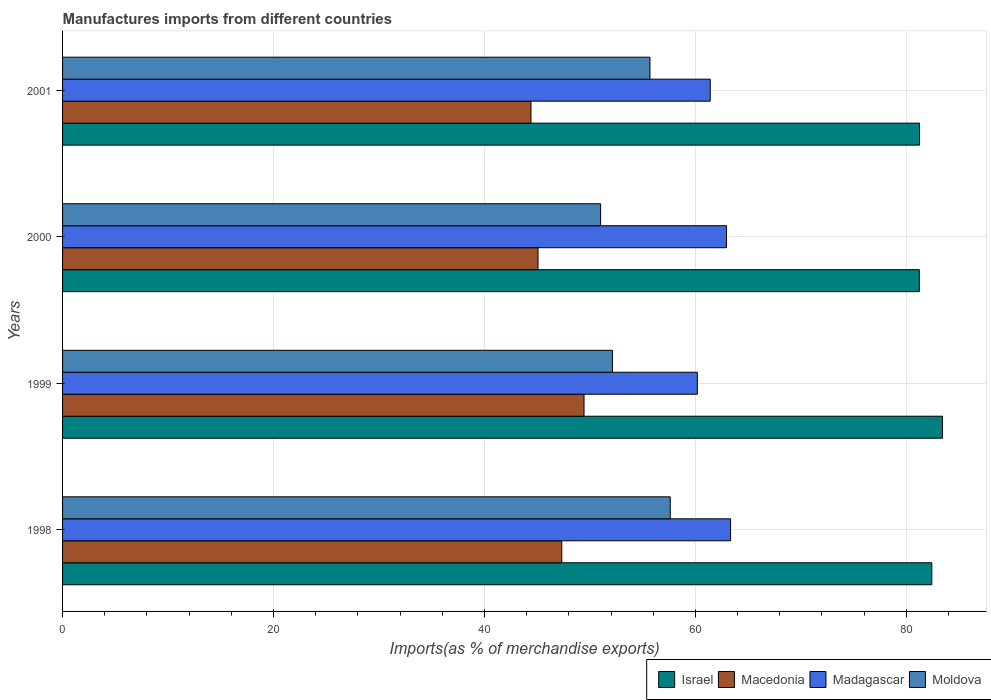How many groups of bars are there?
Provide a succinct answer. 4. Are the number of bars on each tick of the Y-axis equal?
Offer a very short reply. Yes. How many bars are there on the 1st tick from the top?
Ensure brevity in your answer.  4. In how many cases, is the number of bars for a given year not equal to the number of legend labels?
Your answer should be compact. 0. What is the percentage of imports to different countries in Madagascar in 2000?
Make the answer very short. 62.95. Across all years, what is the maximum percentage of imports to different countries in Moldova?
Provide a short and direct response. 57.62. Across all years, what is the minimum percentage of imports to different countries in Israel?
Your answer should be very brief. 81.23. In which year was the percentage of imports to different countries in Israel maximum?
Ensure brevity in your answer.  1999. What is the total percentage of imports to different countries in Madagascar in the graph?
Your answer should be very brief. 247.88. What is the difference between the percentage of imports to different countries in Macedonia in 2000 and that in 2001?
Your answer should be compact. 0.66. What is the difference between the percentage of imports to different countries in Madagascar in 2000 and the percentage of imports to different countries in Macedonia in 1998?
Provide a succinct answer. 15.62. What is the average percentage of imports to different countries in Israel per year?
Offer a terse response. 82.08. In the year 1999, what is the difference between the percentage of imports to different countries in Madagascar and percentage of imports to different countries in Israel?
Give a very brief answer. -23.25. What is the ratio of the percentage of imports to different countries in Israel in 1999 to that in 2000?
Your response must be concise. 1.03. Is the percentage of imports to different countries in Israel in 1998 less than that in 2000?
Make the answer very short. No. Is the difference between the percentage of imports to different countries in Madagascar in 1999 and 2000 greater than the difference between the percentage of imports to different countries in Israel in 1999 and 2000?
Ensure brevity in your answer.  No. What is the difference between the highest and the second highest percentage of imports to different countries in Israel?
Give a very brief answer. 1.01. What is the difference between the highest and the lowest percentage of imports to different countries in Israel?
Ensure brevity in your answer.  2.2. Is the sum of the percentage of imports to different countries in Moldova in 1998 and 2001 greater than the maximum percentage of imports to different countries in Macedonia across all years?
Your answer should be compact. Yes. What does the 3rd bar from the top in 2000 represents?
Keep it short and to the point. Macedonia. What does the 4th bar from the bottom in 2001 represents?
Keep it short and to the point. Moldova. How many bars are there?
Offer a terse response. 16. Are all the bars in the graph horizontal?
Your answer should be compact. Yes. How many years are there in the graph?
Your answer should be very brief. 4. What is the difference between two consecutive major ticks on the X-axis?
Offer a very short reply. 20. Are the values on the major ticks of X-axis written in scientific E-notation?
Keep it short and to the point. No. Does the graph contain any zero values?
Your answer should be compact. No. Does the graph contain grids?
Provide a short and direct response. Yes. Where does the legend appear in the graph?
Provide a short and direct response. Bottom right. What is the title of the graph?
Provide a succinct answer. Manufactures imports from different countries. Does "Belgium" appear as one of the legend labels in the graph?
Give a very brief answer. No. What is the label or title of the X-axis?
Your answer should be compact. Imports(as % of merchandise exports). What is the Imports(as % of merchandise exports) in Israel in 1998?
Your answer should be very brief. 82.42. What is the Imports(as % of merchandise exports) of Macedonia in 1998?
Give a very brief answer. 47.33. What is the Imports(as % of merchandise exports) of Madagascar in 1998?
Ensure brevity in your answer.  63.33. What is the Imports(as % of merchandise exports) in Moldova in 1998?
Make the answer very short. 57.62. What is the Imports(as % of merchandise exports) of Israel in 1999?
Your answer should be very brief. 83.43. What is the Imports(as % of merchandise exports) in Macedonia in 1999?
Your answer should be very brief. 49.44. What is the Imports(as % of merchandise exports) of Madagascar in 1999?
Offer a terse response. 60.18. What is the Imports(as % of merchandise exports) of Moldova in 1999?
Provide a short and direct response. 52.14. What is the Imports(as % of merchandise exports) in Israel in 2000?
Make the answer very short. 81.23. What is the Imports(as % of merchandise exports) of Macedonia in 2000?
Give a very brief answer. 45.08. What is the Imports(as % of merchandise exports) in Madagascar in 2000?
Offer a terse response. 62.95. What is the Imports(as % of merchandise exports) of Moldova in 2000?
Your answer should be very brief. 51.02. What is the Imports(as % of merchandise exports) of Israel in 2001?
Your answer should be compact. 81.25. What is the Imports(as % of merchandise exports) in Macedonia in 2001?
Ensure brevity in your answer.  44.41. What is the Imports(as % of merchandise exports) in Madagascar in 2001?
Give a very brief answer. 61.41. What is the Imports(as % of merchandise exports) of Moldova in 2001?
Provide a succinct answer. 55.69. Across all years, what is the maximum Imports(as % of merchandise exports) in Israel?
Your answer should be very brief. 83.43. Across all years, what is the maximum Imports(as % of merchandise exports) of Macedonia?
Your answer should be very brief. 49.44. Across all years, what is the maximum Imports(as % of merchandise exports) of Madagascar?
Your response must be concise. 63.33. Across all years, what is the maximum Imports(as % of merchandise exports) in Moldova?
Provide a short and direct response. 57.62. Across all years, what is the minimum Imports(as % of merchandise exports) in Israel?
Your answer should be very brief. 81.23. Across all years, what is the minimum Imports(as % of merchandise exports) of Macedonia?
Your response must be concise. 44.41. Across all years, what is the minimum Imports(as % of merchandise exports) of Madagascar?
Make the answer very short. 60.18. Across all years, what is the minimum Imports(as % of merchandise exports) of Moldova?
Offer a very short reply. 51.02. What is the total Imports(as % of merchandise exports) of Israel in the graph?
Offer a terse response. 328.33. What is the total Imports(as % of merchandise exports) in Macedonia in the graph?
Provide a short and direct response. 186.27. What is the total Imports(as % of merchandise exports) in Madagascar in the graph?
Ensure brevity in your answer.  247.88. What is the total Imports(as % of merchandise exports) in Moldova in the graph?
Your answer should be very brief. 216.46. What is the difference between the Imports(as % of merchandise exports) of Israel in 1998 and that in 1999?
Offer a terse response. -1.01. What is the difference between the Imports(as % of merchandise exports) of Macedonia in 1998 and that in 1999?
Your answer should be compact. -2.11. What is the difference between the Imports(as % of merchandise exports) of Madagascar in 1998 and that in 1999?
Make the answer very short. 3.15. What is the difference between the Imports(as % of merchandise exports) of Moldova in 1998 and that in 1999?
Give a very brief answer. 5.48. What is the difference between the Imports(as % of merchandise exports) in Israel in 1998 and that in 2000?
Give a very brief answer. 1.18. What is the difference between the Imports(as % of merchandise exports) of Macedonia in 1998 and that in 2000?
Provide a short and direct response. 2.26. What is the difference between the Imports(as % of merchandise exports) of Madagascar in 1998 and that in 2000?
Offer a terse response. 0.39. What is the difference between the Imports(as % of merchandise exports) of Moldova in 1998 and that in 2000?
Your answer should be compact. 6.6. What is the difference between the Imports(as % of merchandise exports) in Israel in 1998 and that in 2001?
Offer a terse response. 1.16. What is the difference between the Imports(as % of merchandise exports) of Macedonia in 1998 and that in 2001?
Ensure brevity in your answer.  2.92. What is the difference between the Imports(as % of merchandise exports) of Madagascar in 1998 and that in 2001?
Your response must be concise. 1.93. What is the difference between the Imports(as % of merchandise exports) of Moldova in 1998 and that in 2001?
Ensure brevity in your answer.  1.92. What is the difference between the Imports(as % of merchandise exports) of Israel in 1999 and that in 2000?
Give a very brief answer. 2.2. What is the difference between the Imports(as % of merchandise exports) in Macedonia in 1999 and that in 2000?
Keep it short and to the point. 4.37. What is the difference between the Imports(as % of merchandise exports) in Madagascar in 1999 and that in 2000?
Keep it short and to the point. -2.77. What is the difference between the Imports(as % of merchandise exports) in Moldova in 1999 and that in 2000?
Ensure brevity in your answer.  1.12. What is the difference between the Imports(as % of merchandise exports) in Israel in 1999 and that in 2001?
Make the answer very short. 2.18. What is the difference between the Imports(as % of merchandise exports) in Macedonia in 1999 and that in 2001?
Provide a short and direct response. 5.03. What is the difference between the Imports(as % of merchandise exports) of Madagascar in 1999 and that in 2001?
Keep it short and to the point. -1.23. What is the difference between the Imports(as % of merchandise exports) in Moldova in 1999 and that in 2001?
Your response must be concise. -3.56. What is the difference between the Imports(as % of merchandise exports) of Israel in 2000 and that in 2001?
Offer a very short reply. -0.02. What is the difference between the Imports(as % of merchandise exports) in Macedonia in 2000 and that in 2001?
Ensure brevity in your answer.  0.66. What is the difference between the Imports(as % of merchandise exports) in Madagascar in 2000 and that in 2001?
Give a very brief answer. 1.54. What is the difference between the Imports(as % of merchandise exports) in Moldova in 2000 and that in 2001?
Ensure brevity in your answer.  -4.68. What is the difference between the Imports(as % of merchandise exports) in Israel in 1998 and the Imports(as % of merchandise exports) in Macedonia in 1999?
Offer a very short reply. 32.97. What is the difference between the Imports(as % of merchandise exports) of Israel in 1998 and the Imports(as % of merchandise exports) of Madagascar in 1999?
Provide a short and direct response. 22.23. What is the difference between the Imports(as % of merchandise exports) of Israel in 1998 and the Imports(as % of merchandise exports) of Moldova in 1999?
Your answer should be compact. 30.28. What is the difference between the Imports(as % of merchandise exports) in Macedonia in 1998 and the Imports(as % of merchandise exports) in Madagascar in 1999?
Provide a succinct answer. -12.85. What is the difference between the Imports(as % of merchandise exports) in Macedonia in 1998 and the Imports(as % of merchandise exports) in Moldova in 1999?
Offer a terse response. -4.8. What is the difference between the Imports(as % of merchandise exports) of Madagascar in 1998 and the Imports(as % of merchandise exports) of Moldova in 1999?
Offer a very short reply. 11.2. What is the difference between the Imports(as % of merchandise exports) in Israel in 1998 and the Imports(as % of merchandise exports) in Macedonia in 2000?
Make the answer very short. 37.34. What is the difference between the Imports(as % of merchandise exports) in Israel in 1998 and the Imports(as % of merchandise exports) in Madagascar in 2000?
Your answer should be very brief. 19.47. What is the difference between the Imports(as % of merchandise exports) in Israel in 1998 and the Imports(as % of merchandise exports) in Moldova in 2000?
Give a very brief answer. 31.4. What is the difference between the Imports(as % of merchandise exports) in Macedonia in 1998 and the Imports(as % of merchandise exports) in Madagascar in 2000?
Your answer should be very brief. -15.62. What is the difference between the Imports(as % of merchandise exports) of Macedonia in 1998 and the Imports(as % of merchandise exports) of Moldova in 2000?
Your response must be concise. -3.68. What is the difference between the Imports(as % of merchandise exports) of Madagascar in 1998 and the Imports(as % of merchandise exports) of Moldova in 2000?
Ensure brevity in your answer.  12.32. What is the difference between the Imports(as % of merchandise exports) of Israel in 1998 and the Imports(as % of merchandise exports) of Macedonia in 2001?
Offer a terse response. 38. What is the difference between the Imports(as % of merchandise exports) in Israel in 1998 and the Imports(as % of merchandise exports) in Madagascar in 2001?
Keep it short and to the point. 21.01. What is the difference between the Imports(as % of merchandise exports) of Israel in 1998 and the Imports(as % of merchandise exports) of Moldova in 2001?
Provide a short and direct response. 26.72. What is the difference between the Imports(as % of merchandise exports) in Macedonia in 1998 and the Imports(as % of merchandise exports) in Madagascar in 2001?
Make the answer very short. -14.08. What is the difference between the Imports(as % of merchandise exports) in Macedonia in 1998 and the Imports(as % of merchandise exports) in Moldova in 2001?
Ensure brevity in your answer.  -8.36. What is the difference between the Imports(as % of merchandise exports) of Madagascar in 1998 and the Imports(as % of merchandise exports) of Moldova in 2001?
Offer a very short reply. 7.64. What is the difference between the Imports(as % of merchandise exports) in Israel in 1999 and the Imports(as % of merchandise exports) in Macedonia in 2000?
Give a very brief answer. 38.35. What is the difference between the Imports(as % of merchandise exports) of Israel in 1999 and the Imports(as % of merchandise exports) of Madagascar in 2000?
Provide a short and direct response. 20.48. What is the difference between the Imports(as % of merchandise exports) in Israel in 1999 and the Imports(as % of merchandise exports) in Moldova in 2000?
Provide a short and direct response. 32.41. What is the difference between the Imports(as % of merchandise exports) in Macedonia in 1999 and the Imports(as % of merchandise exports) in Madagascar in 2000?
Your answer should be compact. -13.51. What is the difference between the Imports(as % of merchandise exports) in Macedonia in 1999 and the Imports(as % of merchandise exports) in Moldova in 2000?
Keep it short and to the point. -1.57. What is the difference between the Imports(as % of merchandise exports) of Madagascar in 1999 and the Imports(as % of merchandise exports) of Moldova in 2000?
Your answer should be compact. 9.17. What is the difference between the Imports(as % of merchandise exports) of Israel in 1999 and the Imports(as % of merchandise exports) of Macedonia in 2001?
Ensure brevity in your answer.  39.02. What is the difference between the Imports(as % of merchandise exports) in Israel in 1999 and the Imports(as % of merchandise exports) in Madagascar in 2001?
Ensure brevity in your answer.  22.02. What is the difference between the Imports(as % of merchandise exports) of Israel in 1999 and the Imports(as % of merchandise exports) of Moldova in 2001?
Provide a succinct answer. 27.74. What is the difference between the Imports(as % of merchandise exports) in Macedonia in 1999 and the Imports(as % of merchandise exports) in Madagascar in 2001?
Provide a short and direct response. -11.97. What is the difference between the Imports(as % of merchandise exports) in Macedonia in 1999 and the Imports(as % of merchandise exports) in Moldova in 2001?
Give a very brief answer. -6.25. What is the difference between the Imports(as % of merchandise exports) in Madagascar in 1999 and the Imports(as % of merchandise exports) in Moldova in 2001?
Offer a very short reply. 4.49. What is the difference between the Imports(as % of merchandise exports) in Israel in 2000 and the Imports(as % of merchandise exports) in Macedonia in 2001?
Your answer should be very brief. 36.82. What is the difference between the Imports(as % of merchandise exports) in Israel in 2000 and the Imports(as % of merchandise exports) in Madagascar in 2001?
Make the answer very short. 19.82. What is the difference between the Imports(as % of merchandise exports) of Israel in 2000 and the Imports(as % of merchandise exports) of Moldova in 2001?
Keep it short and to the point. 25.54. What is the difference between the Imports(as % of merchandise exports) of Macedonia in 2000 and the Imports(as % of merchandise exports) of Madagascar in 2001?
Ensure brevity in your answer.  -16.33. What is the difference between the Imports(as % of merchandise exports) of Macedonia in 2000 and the Imports(as % of merchandise exports) of Moldova in 2001?
Your answer should be compact. -10.62. What is the difference between the Imports(as % of merchandise exports) of Madagascar in 2000 and the Imports(as % of merchandise exports) of Moldova in 2001?
Your response must be concise. 7.25. What is the average Imports(as % of merchandise exports) in Israel per year?
Your response must be concise. 82.08. What is the average Imports(as % of merchandise exports) in Macedonia per year?
Ensure brevity in your answer.  46.57. What is the average Imports(as % of merchandise exports) of Madagascar per year?
Ensure brevity in your answer.  61.97. What is the average Imports(as % of merchandise exports) of Moldova per year?
Ensure brevity in your answer.  54.12. In the year 1998, what is the difference between the Imports(as % of merchandise exports) in Israel and Imports(as % of merchandise exports) in Macedonia?
Offer a terse response. 35.08. In the year 1998, what is the difference between the Imports(as % of merchandise exports) in Israel and Imports(as % of merchandise exports) in Madagascar?
Offer a terse response. 19.08. In the year 1998, what is the difference between the Imports(as % of merchandise exports) of Israel and Imports(as % of merchandise exports) of Moldova?
Make the answer very short. 24.8. In the year 1998, what is the difference between the Imports(as % of merchandise exports) of Macedonia and Imports(as % of merchandise exports) of Madagascar?
Offer a terse response. -16. In the year 1998, what is the difference between the Imports(as % of merchandise exports) in Macedonia and Imports(as % of merchandise exports) in Moldova?
Your answer should be compact. -10.28. In the year 1998, what is the difference between the Imports(as % of merchandise exports) of Madagascar and Imports(as % of merchandise exports) of Moldova?
Offer a terse response. 5.72. In the year 1999, what is the difference between the Imports(as % of merchandise exports) of Israel and Imports(as % of merchandise exports) of Macedonia?
Provide a succinct answer. 33.99. In the year 1999, what is the difference between the Imports(as % of merchandise exports) of Israel and Imports(as % of merchandise exports) of Madagascar?
Make the answer very short. 23.25. In the year 1999, what is the difference between the Imports(as % of merchandise exports) in Israel and Imports(as % of merchandise exports) in Moldova?
Provide a short and direct response. 31.29. In the year 1999, what is the difference between the Imports(as % of merchandise exports) of Macedonia and Imports(as % of merchandise exports) of Madagascar?
Keep it short and to the point. -10.74. In the year 1999, what is the difference between the Imports(as % of merchandise exports) in Macedonia and Imports(as % of merchandise exports) in Moldova?
Your response must be concise. -2.69. In the year 1999, what is the difference between the Imports(as % of merchandise exports) in Madagascar and Imports(as % of merchandise exports) in Moldova?
Keep it short and to the point. 8.05. In the year 2000, what is the difference between the Imports(as % of merchandise exports) in Israel and Imports(as % of merchandise exports) in Macedonia?
Offer a very short reply. 36.16. In the year 2000, what is the difference between the Imports(as % of merchandise exports) in Israel and Imports(as % of merchandise exports) in Madagascar?
Offer a terse response. 18.28. In the year 2000, what is the difference between the Imports(as % of merchandise exports) in Israel and Imports(as % of merchandise exports) in Moldova?
Make the answer very short. 30.22. In the year 2000, what is the difference between the Imports(as % of merchandise exports) in Macedonia and Imports(as % of merchandise exports) in Madagascar?
Offer a very short reply. -17.87. In the year 2000, what is the difference between the Imports(as % of merchandise exports) in Macedonia and Imports(as % of merchandise exports) in Moldova?
Provide a short and direct response. -5.94. In the year 2000, what is the difference between the Imports(as % of merchandise exports) of Madagascar and Imports(as % of merchandise exports) of Moldova?
Provide a succinct answer. 11.93. In the year 2001, what is the difference between the Imports(as % of merchandise exports) of Israel and Imports(as % of merchandise exports) of Macedonia?
Offer a terse response. 36.84. In the year 2001, what is the difference between the Imports(as % of merchandise exports) in Israel and Imports(as % of merchandise exports) in Madagascar?
Ensure brevity in your answer.  19.84. In the year 2001, what is the difference between the Imports(as % of merchandise exports) in Israel and Imports(as % of merchandise exports) in Moldova?
Your answer should be very brief. 25.56. In the year 2001, what is the difference between the Imports(as % of merchandise exports) of Macedonia and Imports(as % of merchandise exports) of Madagascar?
Provide a succinct answer. -17. In the year 2001, what is the difference between the Imports(as % of merchandise exports) in Macedonia and Imports(as % of merchandise exports) in Moldova?
Your response must be concise. -11.28. In the year 2001, what is the difference between the Imports(as % of merchandise exports) of Madagascar and Imports(as % of merchandise exports) of Moldova?
Keep it short and to the point. 5.72. What is the ratio of the Imports(as % of merchandise exports) of Israel in 1998 to that in 1999?
Provide a succinct answer. 0.99. What is the ratio of the Imports(as % of merchandise exports) in Macedonia in 1998 to that in 1999?
Keep it short and to the point. 0.96. What is the ratio of the Imports(as % of merchandise exports) in Madagascar in 1998 to that in 1999?
Offer a very short reply. 1.05. What is the ratio of the Imports(as % of merchandise exports) of Moldova in 1998 to that in 1999?
Your response must be concise. 1.11. What is the ratio of the Imports(as % of merchandise exports) of Israel in 1998 to that in 2000?
Your response must be concise. 1.01. What is the ratio of the Imports(as % of merchandise exports) in Macedonia in 1998 to that in 2000?
Offer a terse response. 1.05. What is the ratio of the Imports(as % of merchandise exports) in Madagascar in 1998 to that in 2000?
Give a very brief answer. 1.01. What is the ratio of the Imports(as % of merchandise exports) in Moldova in 1998 to that in 2000?
Your answer should be compact. 1.13. What is the ratio of the Imports(as % of merchandise exports) in Israel in 1998 to that in 2001?
Provide a succinct answer. 1.01. What is the ratio of the Imports(as % of merchandise exports) of Macedonia in 1998 to that in 2001?
Provide a short and direct response. 1.07. What is the ratio of the Imports(as % of merchandise exports) of Madagascar in 1998 to that in 2001?
Your response must be concise. 1.03. What is the ratio of the Imports(as % of merchandise exports) of Moldova in 1998 to that in 2001?
Provide a short and direct response. 1.03. What is the ratio of the Imports(as % of merchandise exports) of Macedonia in 1999 to that in 2000?
Keep it short and to the point. 1.1. What is the ratio of the Imports(as % of merchandise exports) of Madagascar in 1999 to that in 2000?
Give a very brief answer. 0.96. What is the ratio of the Imports(as % of merchandise exports) of Israel in 1999 to that in 2001?
Your answer should be very brief. 1.03. What is the ratio of the Imports(as % of merchandise exports) in Macedonia in 1999 to that in 2001?
Offer a very short reply. 1.11. What is the ratio of the Imports(as % of merchandise exports) in Moldova in 1999 to that in 2001?
Give a very brief answer. 0.94. What is the ratio of the Imports(as % of merchandise exports) of Israel in 2000 to that in 2001?
Keep it short and to the point. 1. What is the ratio of the Imports(as % of merchandise exports) of Macedonia in 2000 to that in 2001?
Make the answer very short. 1.01. What is the ratio of the Imports(as % of merchandise exports) of Madagascar in 2000 to that in 2001?
Provide a short and direct response. 1.03. What is the ratio of the Imports(as % of merchandise exports) of Moldova in 2000 to that in 2001?
Keep it short and to the point. 0.92. What is the difference between the highest and the second highest Imports(as % of merchandise exports) of Israel?
Offer a terse response. 1.01. What is the difference between the highest and the second highest Imports(as % of merchandise exports) of Macedonia?
Ensure brevity in your answer.  2.11. What is the difference between the highest and the second highest Imports(as % of merchandise exports) in Madagascar?
Keep it short and to the point. 0.39. What is the difference between the highest and the second highest Imports(as % of merchandise exports) in Moldova?
Your response must be concise. 1.92. What is the difference between the highest and the lowest Imports(as % of merchandise exports) in Israel?
Ensure brevity in your answer.  2.2. What is the difference between the highest and the lowest Imports(as % of merchandise exports) of Macedonia?
Keep it short and to the point. 5.03. What is the difference between the highest and the lowest Imports(as % of merchandise exports) in Madagascar?
Ensure brevity in your answer.  3.15. What is the difference between the highest and the lowest Imports(as % of merchandise exports) in Moldova?
Keep it short and to the point. 6.6. 